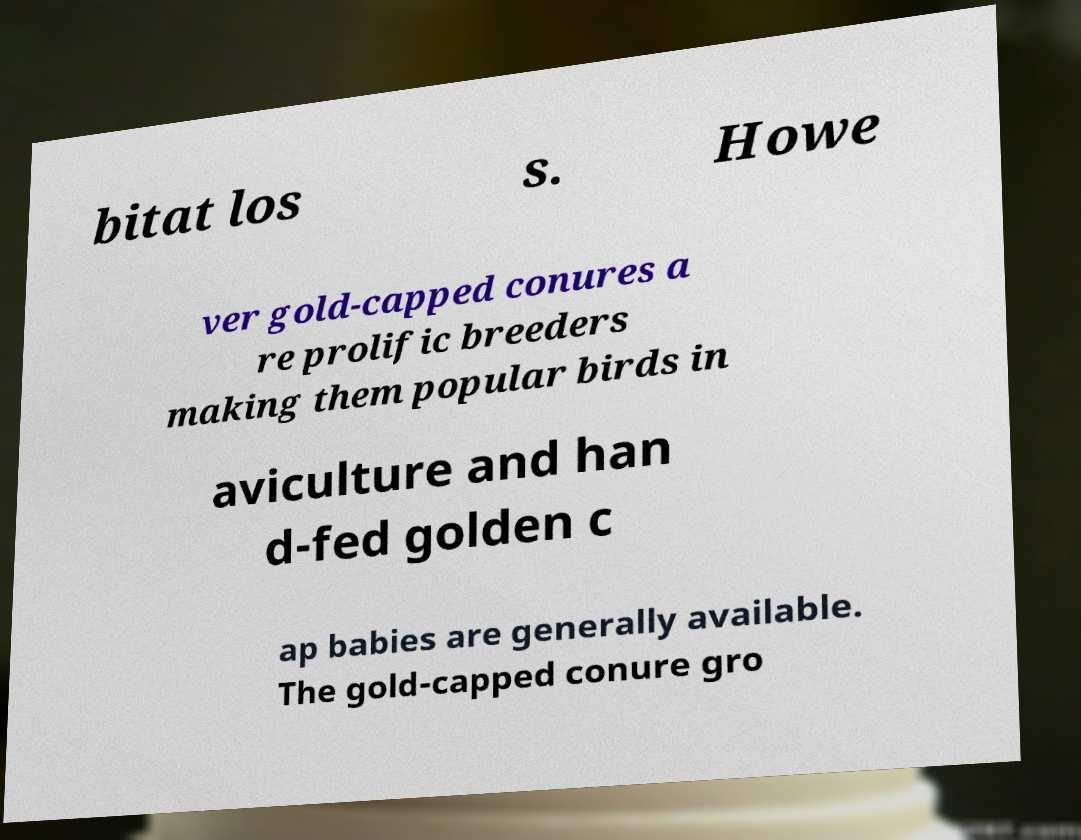What messages or text are displayed in this image? I need them in a readable, typed format. bitat los s. Howe ver gold-capped conures a re prolific breeders making them popular birds in aviculture and han d-fed golden c ap babies are generally available. The gold-capped conure gro 